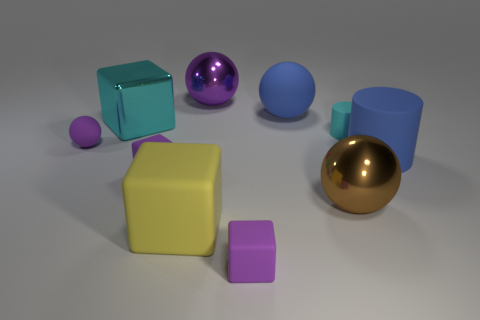Does the metal thing in front of the small cyan cylinder have the same shape as the cyan thing that is to the right of the yellow object?
Give a very brief answer. No. There is a purple thing that is the same size as the brown metal sphere; what is its material?
Provide a short and direct response. Metal. How many other things are there of the same material as the tiny purple ball?
Make the answer very short. 6. The blue rubber object in front of the blue thing behind the small cyan thing is what shape?
Give a very brief answer. Cylinder. What number of objects are tiny green rubber things or rubber objects that are behind the tiny cyan rubber cylinder?
Offer a terse response. 1. What number of other objects are the same color as the large cylinder?
Provide a succinct answer. 1. What number of purple objects are rubber cylinders or matte objects?
Give a very brief answer. 3. There is a small purple thing to the left of the cube behind the purple rubber sphere; are there any small purple objects behind it?
Offer a terse response. No. Do the big matte sphere and the small cylinder have the same color?
Keep it short and to the point. No. There is a big rubber object behind the cylinder in front of the tiny sphere; what color is it?
Give a very brief answer. Blue. 